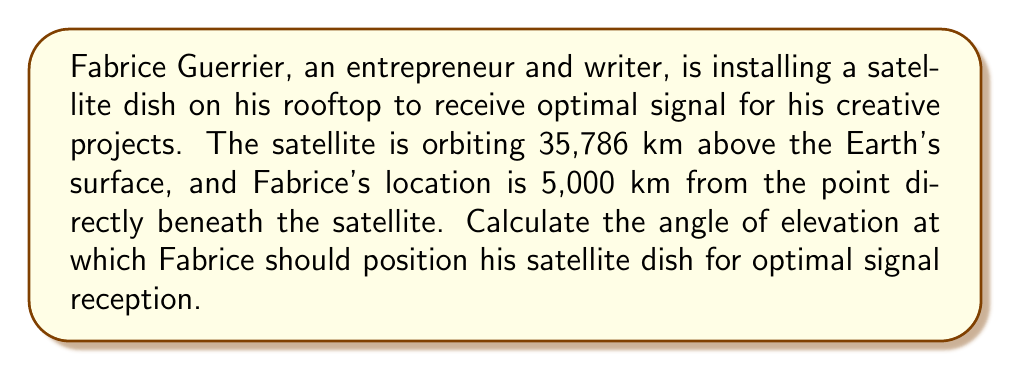Provide a solution to this math problem. To solve this problem, we'll use trigonometry, specifically the arctangent function. Let's break it down step-by-step:

1. Visualize the problem:
   [asy]
   import geometry;
   
   pair A = (0,0);
   pair B = (5,0);
   pair C = (5,3.5786);
   
   draw(A--B--C--A);
   
   label("Earth's surface", (2.5,-0.2), S);
   label("5,000 km", (2.5,0), N);
   label("35,786 km", (5.2,1.75), E);
   label("Satellite", C, NE);
   label("Fabrice", A, SW);
   label("$\theta$", (0.3,0.3), NW);
   
   draw(arc(A,0.5,0,atan(3.5786/5)*180/pi), Arrow);
   [/asy]

2. Identify the known values:
   - Adjacent side (distance on Earth's surface) = 5,000 km
   - Opposite side (satellite's height) = 35,786 km

3. Determine the trigonometric function to use:
   We need to find the angle given the opposite and adjacent sides, so we'll use the arctangent (atan) function.

4. Set up the equation:
   $$\theta = \tan^{-1}\left(\frac{\text{opposite}}{\text{adjacent}}\right)$$

5. Plug in the values:
   $$\theta = \tan^{-1}\left(\frac{35,786}{5,000}\right)$$

6. Calculate the result:
   $$\theta = \tan^{-1}(7.1572)$$
   $$\theta \approx 82.0391^\circ$$

7. Round to a reasonable precision (two decimal places):
   $$\theta \approx 82.04^\circ$$

This angle represents the optimal elevation for Fabrice's satellite dish to receive the best signal.
Answer: $82.04^\circ$ 